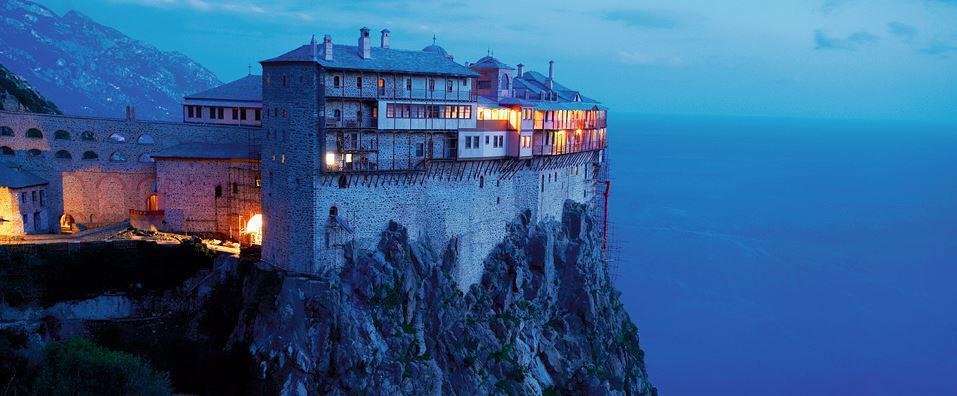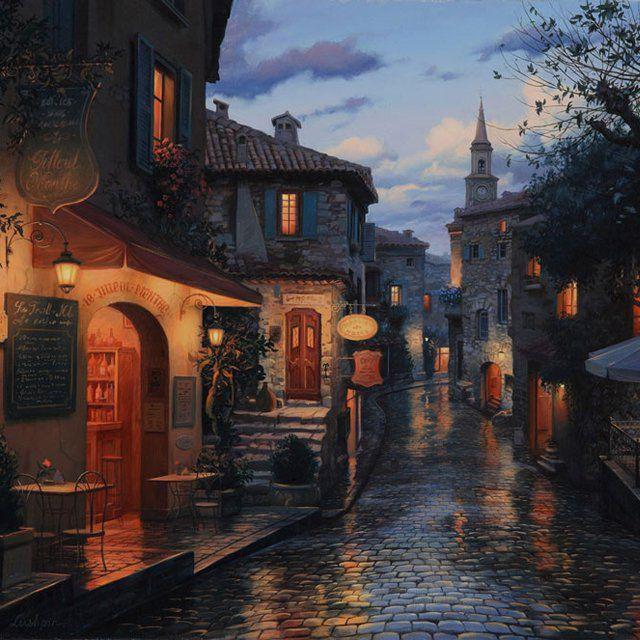The first image is the image on the left, the second image is the image on the right. For the images displayed, is the sentence "The ocean is visible behind the buildings and cliffside in the left image, but it is not visible in the right image." factually correct? Answer yes or no. Yes. 